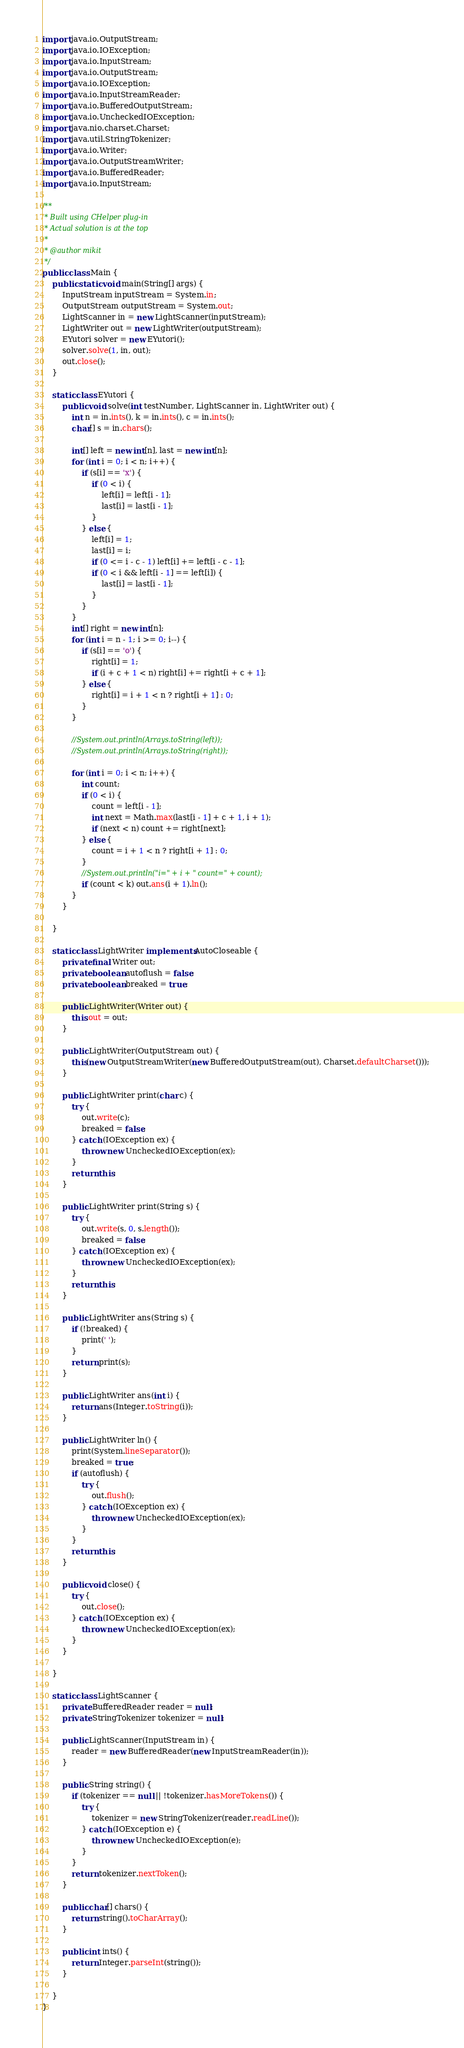<code> <loc_0><loc_0><loc_500><loc_500><_Java_>import java.io.OutputStream;
import java.io.IOException;
import java.io.InputStream;
import java.io.OutputStream;
import java.io.IOException;
import java.io.InputStreamReader;
import java.io.BufferedOutputStream;
import java.io.UncheckedIOException;
import java.nio.charset.Charset;
import java.util.StringTokenizer;
import java.io.Writer;
import java.io.OutputStreamWriter;
import java.io.BufferedReader;
import java.io.InputStream;

/**
 * Built using CHelper plug-in
 * Actual solution is at the top
 *
 * @author mikit
 */
public class Main {
    public static void main(String[] args) {
        InputStream inputStream = System.in;
        OutputStream outputStream = System.out;
        LightScanner in = new LightScanner(inputStream);
        LightWriter out = new LightWriter(outputStream);
        EYutori solver = new EYutori();
        solver.solve(1, in, out);
        out.close();
    }

    static class EYutori {
        public void solve(int testNumber, LightScanner in, LightWriter out) {
            int n = in.ints(), k = in.ints(), c = in.ints();
            char[] s = in.chars();

            int[] left = new int[n], last = new int[n];
            for (int i = 0; i < n; i++) {
                if (s[i] == 'x') {
                    if (0 < i) {
                        left[i] = left[i - 1];
                        last[i] = last[i - 1];
                    }
                } else {
                    left[i] = 1;
                    last[i] = i;
                    if (0 <= i - c - 1) left[i] += left[i - c - 1];
                    if (0 < i && left[i - 1] == left[i]) {
                        last[i] = last[i - 1];
                    }
                }
            }
            int[] right = new int[n];
            for (int i = n - 1; i >= 0; i--) {
                if (s[i] == 'o') {
                    right[i] = 1;
                    if (i + c + 1 < n) right[i] += right[i + c + 1];
                } else {
                    right[i] = i + 1 < n ? right[i + 1] : 0;
                }
            }

            //System.out.println(Arrays.toString(left));
            //System.out.println(Arrays.toString(right));

            for (int i = 0; i < n; i++) {
                int count;
                if (0 < i) {
                    count = left[i - 1];
                    int next = Math.max(last[i - 1] + c + 1, i + 1);
                    if (next < n) count += right[next];
                } else {
                    count = i + 1 < n ? right[i + 1] : 0;
                }
                //System.out.println("i=" + i + " count=" + count);
                if (count < k) out.ans(i + 1).ln();
            }
        }

    }

    static class LightWriter implements AutoCloseable {
        private final Writer out;
        private boolean autoflush = false;
        private boolean breaked = true;

        public LightWriter(Writer out) {
            this.out = out;
        }

        public LightWriter(OutputStream out) {
            this(new OutputStreamWriter(new BufferedOutputStream(out), Charset.defaultCharset()));
        }

        public LightWriter print(char c) {
            try {
                out.write(c);
                breaked = false;
            } catch (IOException ex) {
                throw new UncheckedIOException(ex);
            }
            return this;
        }

        public LightWriter print(String s) {
            try {
                out.write(s, 0, s.length());
                breaked = false;
            } catch (IOException ex) {
                throw new UncheckedIOException(ex);
            }
            return this;
        }

        public LightWriter ans(String s) {
            if (!breaked) {
                print(' ');
            }
            return print(s);
        }

        public LightWriter ans(int i) {
            return ans(Integer.toString(i));
        }

        public LightWriter ln() {
            print(System.lineSeparator());
            breaked = true;
            if (autoflush) {
                try {
                    out.flush();
                } catch (IOException ex) {
                    throw new UncheckedIOException(ex);
                }
            }
            return this;
        }

        public void close() {
            try {
                out.close();
            } catch (IOException ex) {
                throw new UncheckedIOException(ex);
            }
        }

    }

    static class LightScanner {
        private BufferedReader reader = null;
        private StringTokenizer tokenizer = null;

        public LightScanner(InputStream in) {
            reader = new BufferedReader(new InputStreamReader(in));
        }

        public String string() {
            if (tokenizer == null || !tokenizer.hasMoreTokens()) {
                try {
                    tokenizer = new StringTokenizer(reader.readLine());
                } catch (IOException e) {
                    throw new UncheckedIOException(e);
                }
            }
            return tokenizer.nextToken();
        }

        public char[] chars() {
            return string().toCharArray();
        }

        public int ints() {
            return Integer.parseInt(string());
        }

    }
}

</code> 